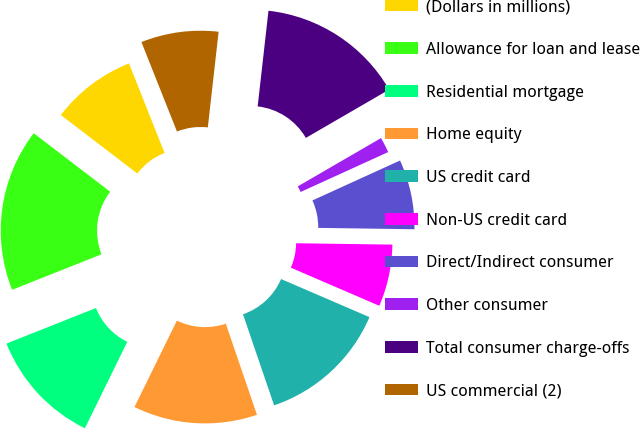Convert chart. <chart><loc_0><loc_0><loc_500><loc_500><pie_chart><fcel>(Dollars in millions)<fcel>Allowance for loan and lease<fcel>Residential mortgage<fcel>Home equity<fcel>US credit card<fcel>Non-US credit card<fcel>Direct/Indirect consumer<fcel>Other consumer<fcel>Total consumer charge-offs<fcel>US commercial (2)<nl><fcel>8.59%<fcel>16.41%<fcel>11.72%<fcel>12.5%<fcel>13.28%<fcel>6.25%<fcel>7.03%<fcel>1.56%<fcel>14.84%<fcel>7.81%<nl></chart> 